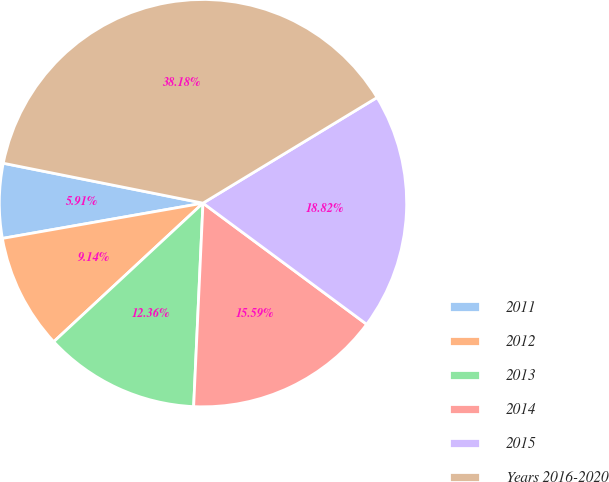<chart> <loc_0><loc_0><loc_500><loc_500><pie_chart><fcel>2011<fcel>2012<fcel>2013<fcel>2014<fcel>2015<fcel>Years 2016-2020<nl><fcel>5.91%<fcel>9.14%<fcel>12.36%<fcel>15.59%<fcel>18.82%<fcel>38.18%<nl></chart> 